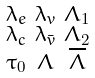Convert formula to latex. <formula><loc_0><loc_0><loc_500><loc_500>\begin{smallmatrix} \lambda _ { e } & \lambda _ { v } & \Lambda _ { 1 } \\ \lambda _ { c } & \lambda _ { \bar { v } } & \Lambda _ { 2 } \\ \tau _ { 0 } & \Lambda & \overline { \Lambda } \end{smallmatrix}</formula> 